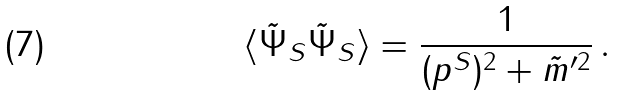Convert formula to latex. <formula><loc_0><loc_0><loc_500><loc_500>\langle \tilde { \Psi } _ { S } \tilde { \Psi } _ { S } \rangle = \frac { 1 } { ( p ^ { S } ) ^ { 2 } + \tilde { m } ^ { \prime 2 } } \, .</formula> 